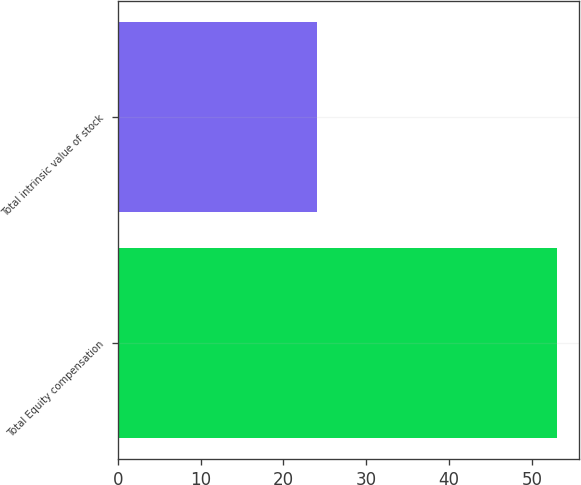Convert chart. <chart><loc_0><loc_0><loc_500><loc_500><bar_chart><fcel>Total Equity compensation<fcel>Total intrinsic value of stock<nl><fcel>53<fcel>24<nl></chart> 